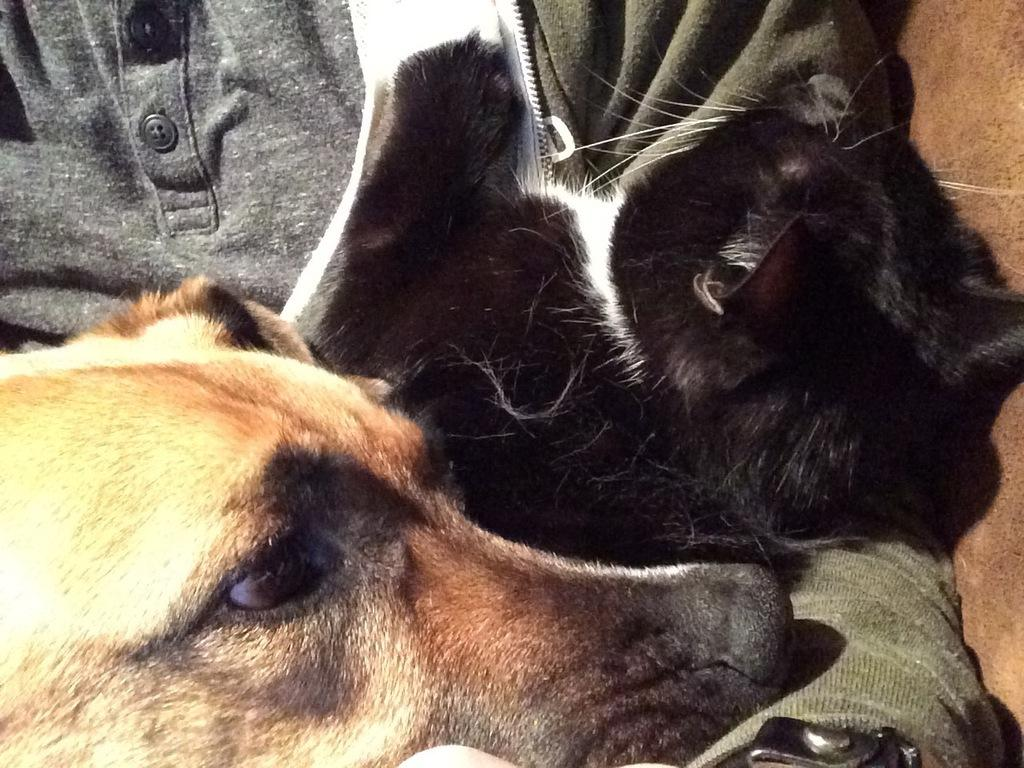What type of animal is in the image? There is a dog in the image. What color is the animal in the image? The animal in the image is black. What can be seen in the background of the image? In the background, there is a person wearing a T-shirt and a person wearing a jacket. What day of the week is depicted in the image? The image does not depict a specific day of the week; it only shows a dog, a black animal, and two people in the background. 